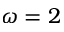<formula> <loc_0><loc_0><loc_500><loc_500>\omega = 2</formula> 